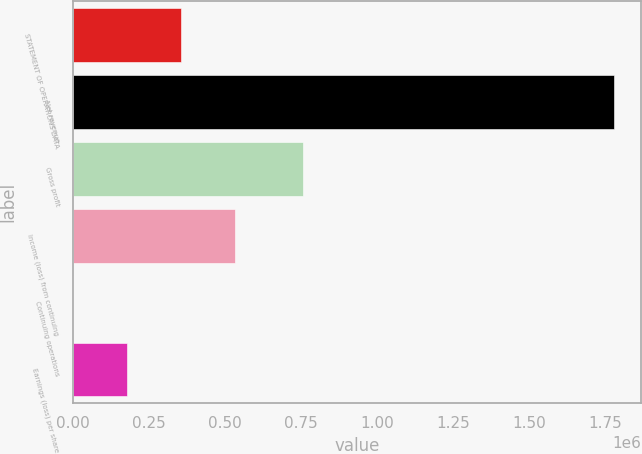<chart> <loc_0><loc_0><loc_500><loc_500><bar_chart><fcel>STATEMENT OF OPERATIONS DATA<fcel>Net revenue<fcel>Gross profit<fcel>Income (loss) from continuing<fcel>Continuing operations<fcel>Earnings (loss) per share<nl><fcel>355950<fcel>1.77975e+06<fcel>756789<fcel>533925<fcel>0.73<fcel>177975<nl></chart> 